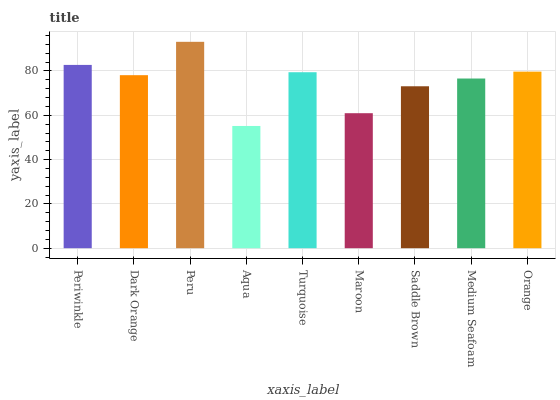Is Aqua the minimum?
Answer yes or no. Yes. Is Peru the maximum?
Answer yes or no. Yes. Is Dark Orange the minimum?
Answer yes or no. No. Is Dark Orange the maximum?
Answer yes or no. No. Is Periwinkle greater than Dark Orange?
Answer yes or no. Yes. Is Dark Orange less than Periwinkle?
Answer yes or no. Yes. Is Dark Orange greater than Periwinkle?
Answer yes or no. No. Is Periwinkle less than Dark Orange?
Answer yes or no. No. Is Dark Orange the high median?
Answer yes or no. Yes. Is Dark Orange the low median?
Answer yes or no. Yes. Is Orange the high median?
Answer yes or no. No. Is Maroon the low median?
Answer yes or no. No. 